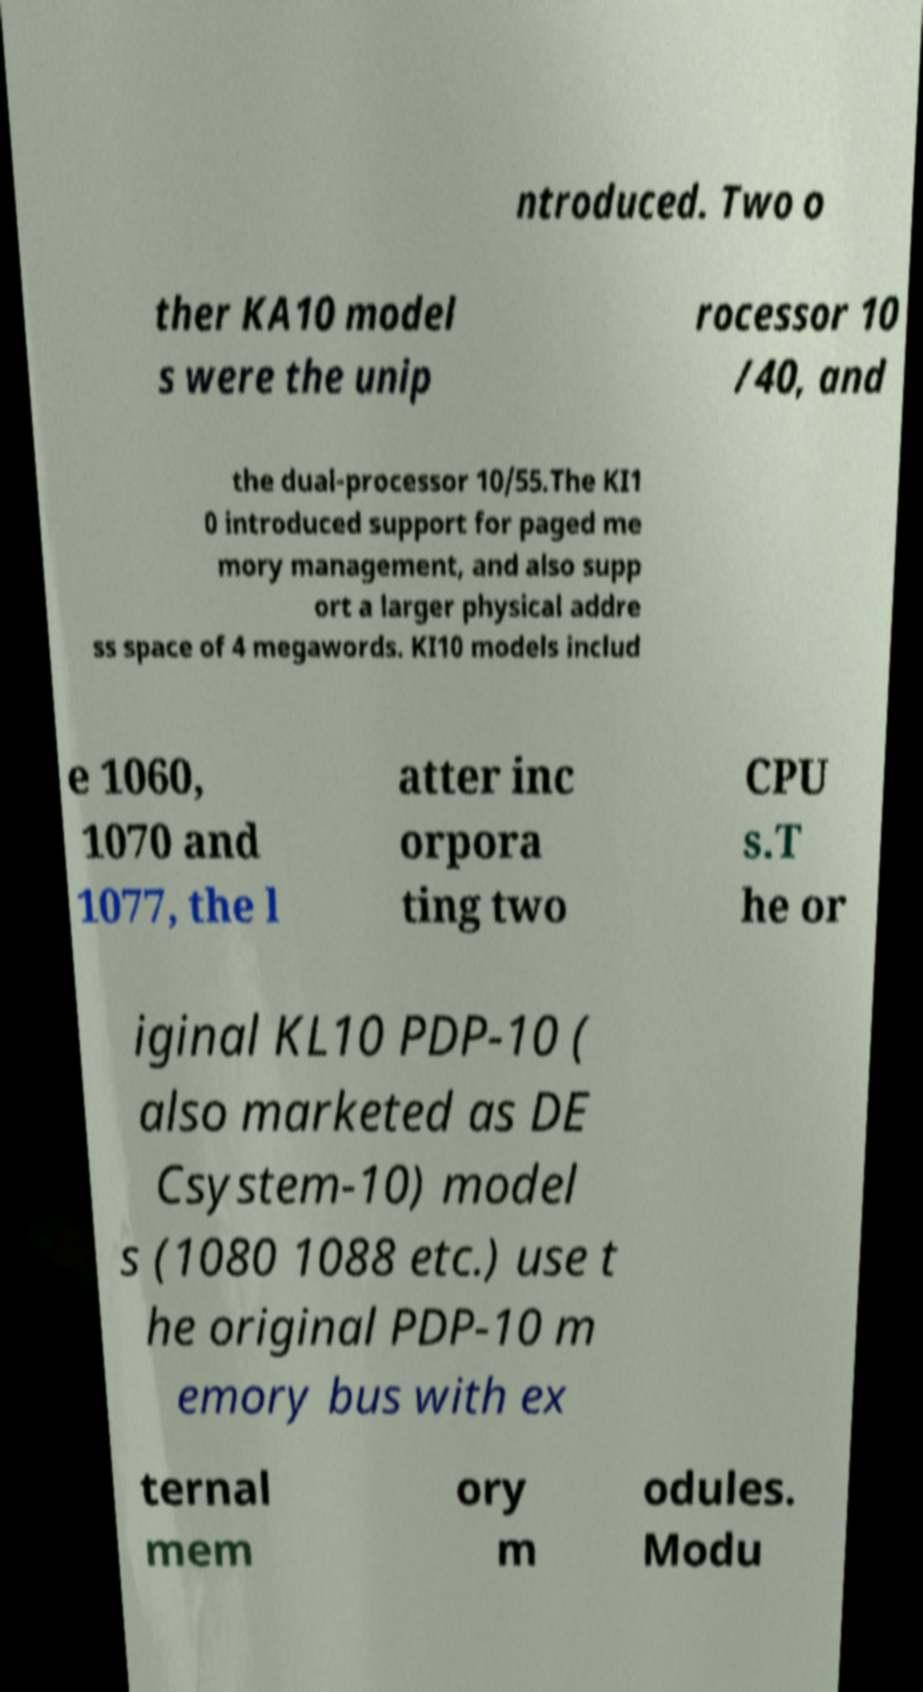Can you read and provide the text displayed in the image?This photo seems to have some interesting text. Can you extract and type it out for me? ntroduced. Two o ther KA10 model s were the unip rocessor 10 /40, and the dual-processor 10/55.The KI1 0 introduced support for paged me mory management, and also supp ort a larger physical addre ss space of 4 megawords. KI10 models includ e 1060, 1070 and 1077, the l atter inc orpora ting two CPU s.T he or iginal KL10 PDP-10 ( also marketed as DE Csystem-10) model s (1080 1088 etc.) use t he original PDP-10 m emory bus with ex ternal mem ory m odules. Modu 